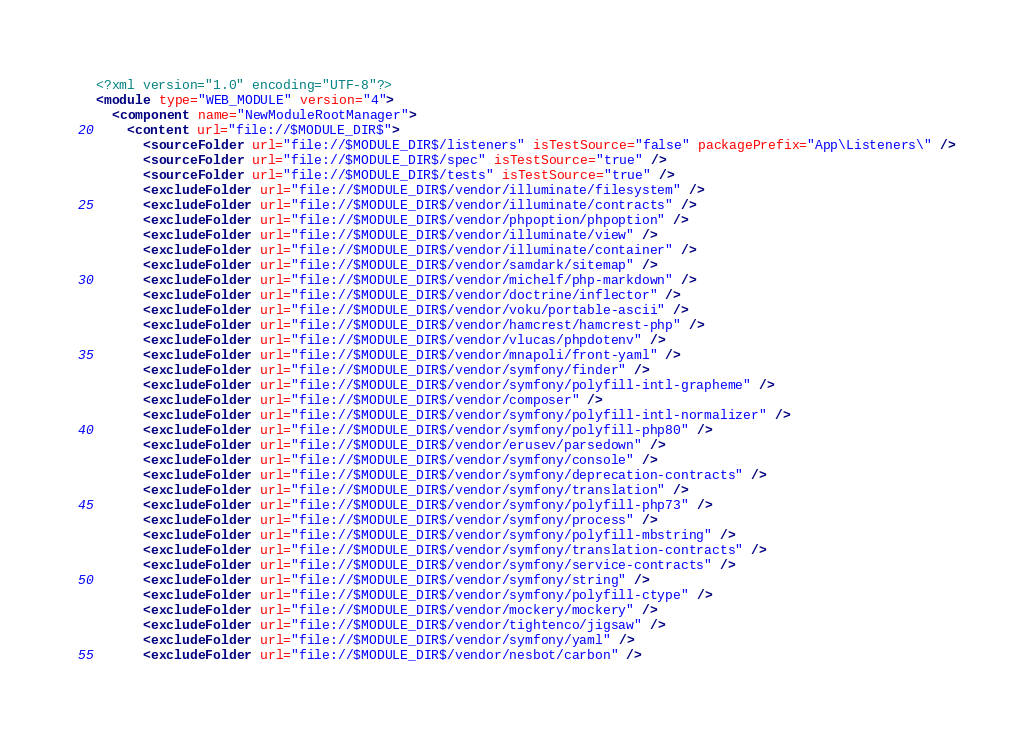Convert code to text. <code><loc_0><loc_0><loc_500><loc_500><_XML_><?xml version="1.0" encoding="UTF-8"?>
<module type="WEB_MODULE" version="4">
  <component name="NewModuleRootManager">
    <content url="file://$MODULE_DIR$">
      <sourceFolder url="file://$MODULE_DIR$/listeners" isTestSource="false" packagePrefix="App\Listeners\" />
      <sourceFolder url="file://$MODULE_DIR$/spec" isTestSource="true" />
      <sourceFolder url="file://$MODULE_DIR$/tests" isTestSource="true" />
      <excludeFolder url="file://$MODULE_DIR$/vendor/illuminate/filesystem" />
      <excludeFolder url="file://$MODULE_DIR$/vendor/illuminate/contracts" />
      <excludeFolder url="file://$MODULE_DIR$/vendor/phpoption/phpoption" />
      <excludeFolder url="file://$MODULE_DIR$/vendor/illuminate/view" />
      <excludeFolder url="file://$MODULE_DIR$/vendor/illuminate/container" />
      <excludeFolder url="file://$MODULE_DIR$/vendor/samdark/sitemap" />
      <excludeFolder url="file://$MODULE_DIR$/vendor/michelf/php-markdown" />
      <excludeFolder url="file://$MODULE_DIR$/vendor/doctrine/inflector" />
      <excludeFolder url="file://$MODULE_DIR$/vendor/voku/portable-ascii" />
      <excludeFolder url="file://$MODULE_DIR$/vendor/hamcrest/hamcrest-php" />
      <excludeFolder url="file://$MODULE_DIR$/vendor/vlucas/phpdotenv" />
      <excludeFolder url="file://$MODULE_DIR$/vendor/mnapoli/front-yaml" />
      <excludeFolder url="file://$MODULE_DIR$/vendor/symfony/finder" />
      <excludeFolder url="file://$MODULE_DIR$/vendor/symfony/polyfill-intl-grapheme" />
      <excludeFolder url="file://$MODULE_DIR$/vendor/composer" />
      <excludeFolder url="file://$MODULE_DIR$/vendor/symfony/polyfill-intl-normalizer" />
      <excludeFolder url="file://$MODULE_DIR$/vendor/symfony/polyfill-php80" />
      <excludeFolder url="file://$MODULE_DIR$/vendor/erusev/parsedown" />
      <excludeFolder url="file://$MODULE_DIR$/vendor/symfony/console" />
      <excludeFolder url="file://$MODULE_DIR$/vendor/symfony/deprecation-contracts" />
      <excludeFolder url="file://$MODULE_DIR$/vendor/symfony/translation" />
      <excludeFolder url="file://$MODULE_DIR$/vendor/symfony/polyfill-php73" />
      <excludeFolder url="file://$MODULE_DIR$/vendor/symfony/process" />
      <excludeFolder url="file://$MODULE_DIR$/vendor/symfony/polyfill-mbstring" />
      <excludeFolder url="file://$MODULE_DIR$/vendor/symfony/translation-contracts" />
      <excludeFolder url="file://$MODULE_DIR$/vendor/symfony/service-contracts" />
      <excludeFolder url="file://$MODULE_DIR$/vendor/symfony/string" />
      <excludeFolder url="file://$MODULE_DIR$/vendor/symfony/polyfill-ctype" />
      <excludeFolder url="file://$MODULE_DIR$/vendor/mockery/mockery" />
      <excludeFolder url="file://$MODULE_DIR$/vendor/tightenco/jigsaw" />
      <excludeFolder url="file://$MODULE_DIR$/vendor/symfony/yaml" />
      <excludeFolder url="file://$MODULE_DIR$/vendor/nesbot/carbon" /></code> 